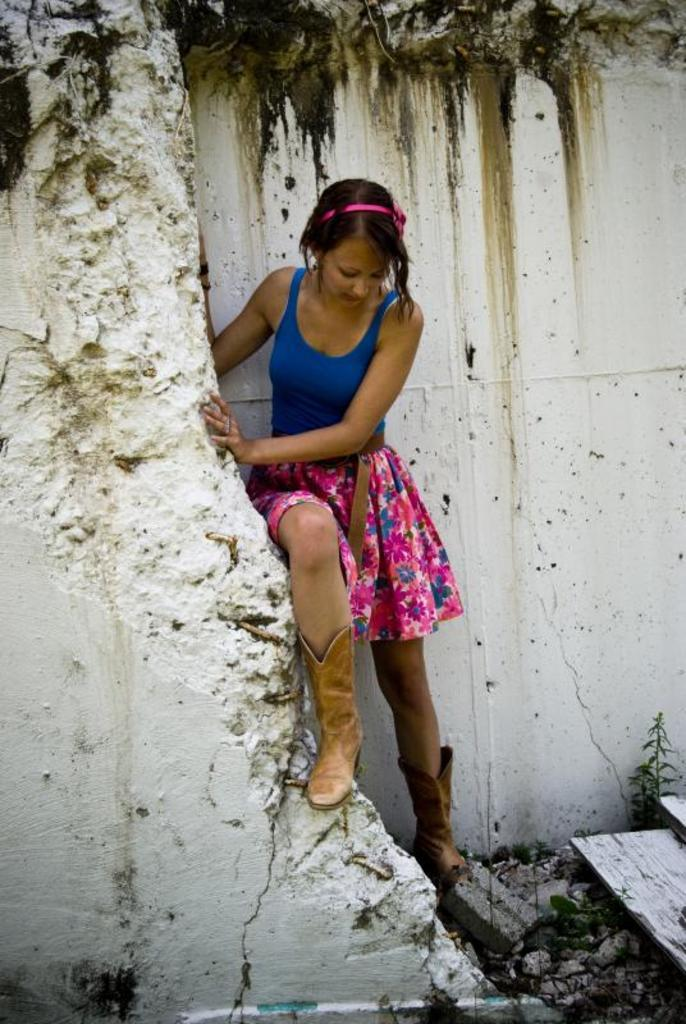Who is the main subject in the front of the image? There is a girl in the front of the image. What can be seen at the bottom of the image? There are stones at the bottom of the image. What type of vegetation is on the right side of the image? There is a plant on the right side of the image. What is visible in the background of the image? There is a wall in the background of the image. Where is the throne located in the image? There is no throne present in the image. What type of development can be seen in the image? The image does not depict any development or construction; it features a girl, stones, a plant, and a wall. 